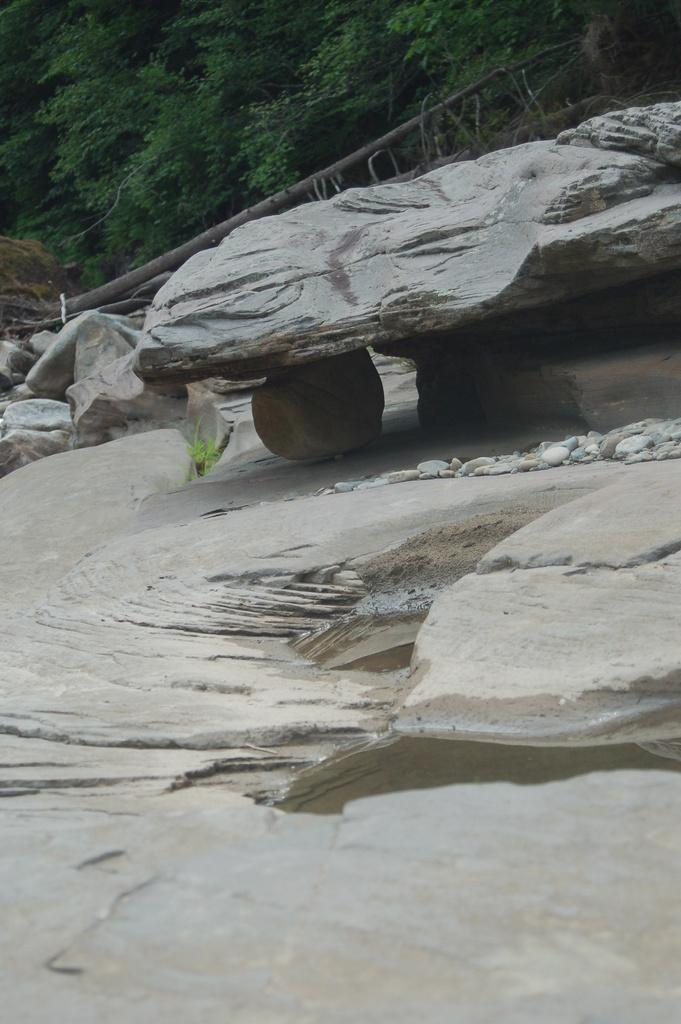What type of vegetation is present in the image? There are green color trees in the image. What else can be seen in the image besides the trees? There are rocks in the image. Where is the shop located in the image? There is no shop present in the image. What type of plant is the cactus in the image? There is no cactus present in the image. 